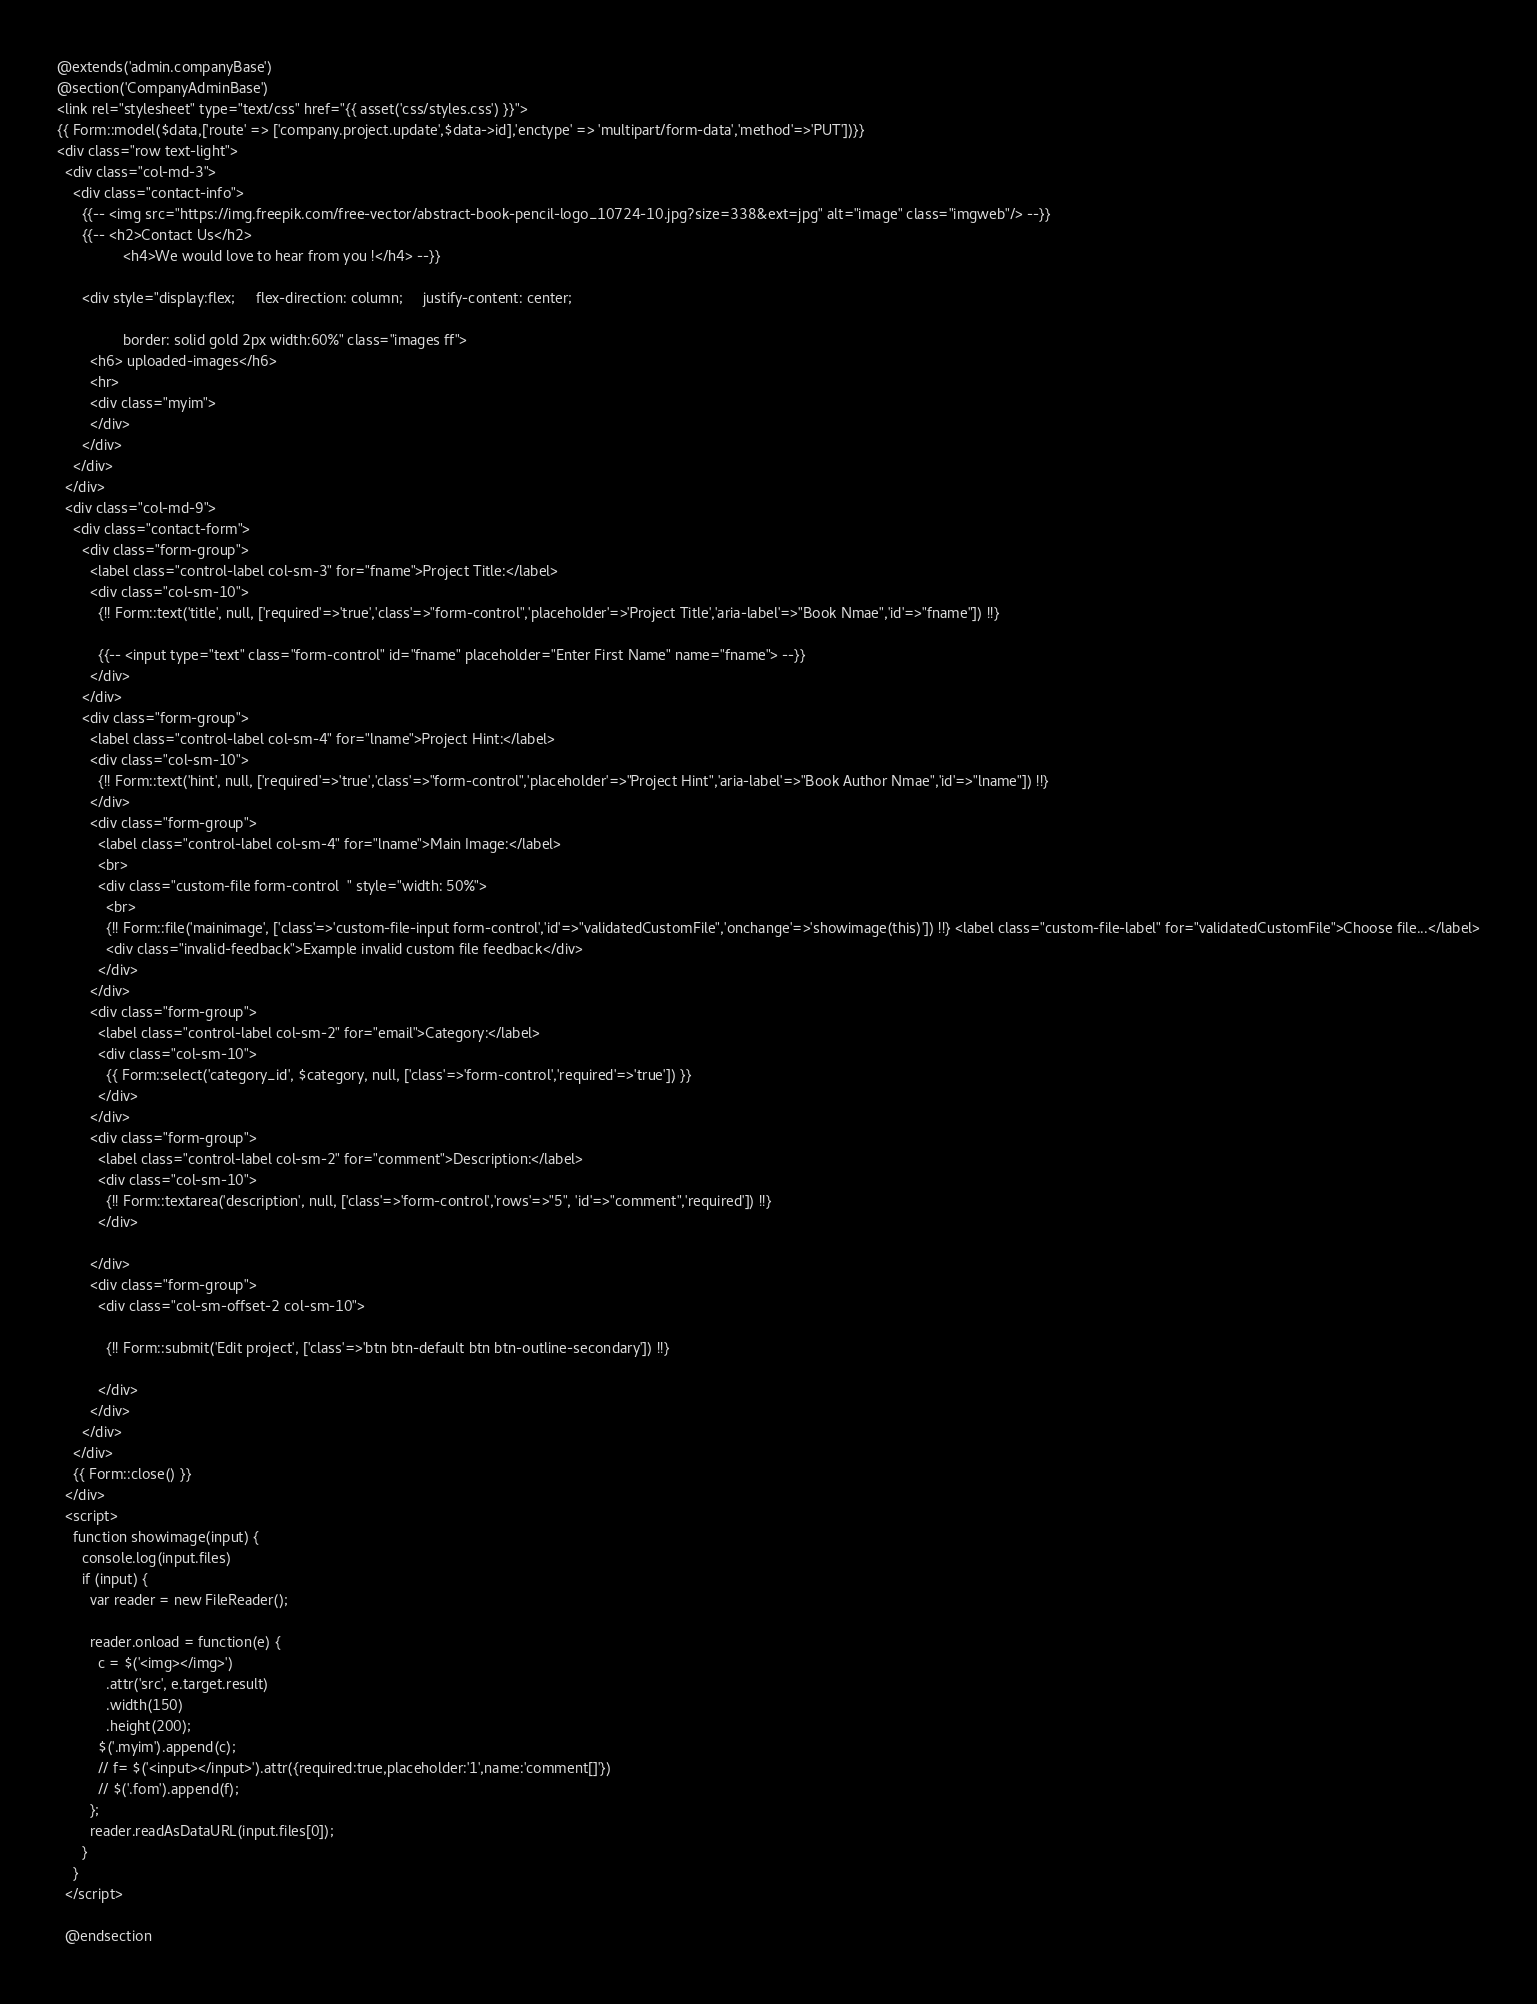<code> <loc_0><loc_0><loc_500><loc_500><_PHP_>@extends('admin.companyBase')
@section('CompanyAdminBase')
<link rel="stylesheet" type="text/css" href="{{ asset('css/styles.css') }}">
{{ Form::model($data,['route' => ['company.project.update',$data->id],'enctype' => 'multipart/form-data','method'=>'PUT'])}}
<div class="row text-light">
  <div class="col-md-3">
    <div class="contact-info">
      {{-- <img src="https://img.freepik.com/free-vector/abstract-book-pencil-logo_10724-10.jpg?size=338&ext=jpg" alt="image" class="imgweb"/> --}}
      {{-- <h2>Contact Us</h2>
                <h4>We would love to hear from you !</h4> --}}

      <div style="display:flex;     flex-direction: column;     justify-content: center;

                border: solid gold 2px width:60%" class="images ff">
        <h6> uploaded-images</h6>
        <hr>
        <div class="myim">
        </div>
      </div>
    </div>
  </div>
  <div class="col-md-9">
    <div class="contact-form">
      <div class="form-group">
        <label class="control-label col-sm-3" for="fname">Project Title:</label>
        <div class="col-sm-10">
          {!! Form::text('title', null, ['required'=>'true','class'=>"form-control",'placeholder'=>'Project Title','aria-label'=>"Book Nmae",'id'=>"fname"]) !!}

          {{-- <input type="text" class="form-control" id="fname" placeholder="Enter First Name" name="fname"> --}}
        </div>
      </div>
      <div class="form-group">
        <label class="control-label col-sm-4" for="lname">Project Hint:</label>
        <div class="col-sm-10">
          {!! Form::text('hint', null, ['required'=>'true','class'=>"form-control",'placeholder'=>"Project Hint",'aria-label'=>"Book Author Nmae",'id'=>"lname"]) !!}
        </div>
        <div class="form-group">
          <label class="control-label col-sm-4" for="lname">Main Image:</label>
          <br>
          <div class="custom-file form-control  " style="width: 50%">
            <br>
            {!! Form::file('mainimage', ['class'=>'custom-file-input form-control','id'=>"validatedCustomFile",'onchange'=>'showimage(this)']) !!} <label class="custom-file-label" for="validatedCustomFile">Choose file...</label>
            <div class="invalid-feedback">Example invalid custom file feedback</div>
          </div>
        </div>
        <div class="form-group">
          <label class="control-label col-sm-2" for="email">Category:</label>
          <div class="col-sm-10">
            {{ Form::select('category_id', $category, null, ['class'=>'form-control','required'=>'true']) }}
          </div>
        </div>
        <div class="form-group">
          <label class="control-label col-sm-2" for="comment">Description:</label>
          <div class="col-sm-10">
            {!! Form::textarea('description', null, ['class'=>'form-control','rows'=>"5", 'id'=>"comment",'required']) !!}
          </div>

        </div>
        <div class="form-group">
          <div class="col-sm-offset-2 col-sm-10">

            {!! Form::submit('Edit project', ['class'=>'btn btn-default btn btn-outline-secondary']) !!}

          </div>
        </div>
      </div>
    </div>
    {{ Form::close() }}
  </div>
  <script>
    function showimage(input) {
      console.log(input.files)
      if (input) {
        var reader = new FileReader();

        reader.onload = function(e) {
          c = $('<img></img>')
            .attr('src', e.target.result)
            .width(150)
            .height(200);
          $('.myim').append(c);
          // f= $('<input></input>').attr({required:true,placeholder:'1',name:'comment[]'})
          // $('.fom').append(f);
        };
        reader.readAsDataURL(input.files[0]);
      }
    }
  </script>

  @endsection</code> 